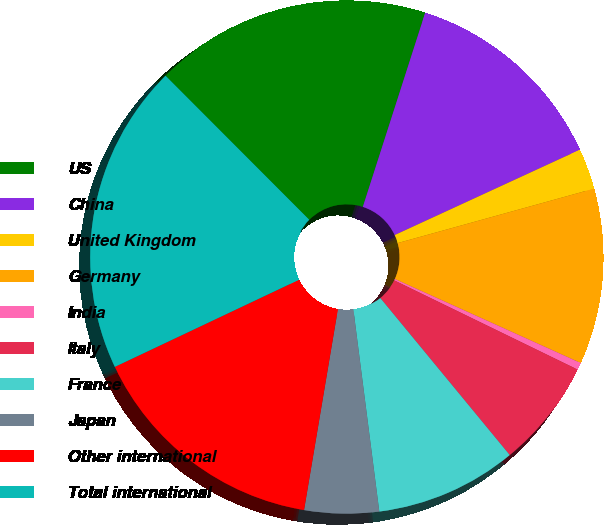Convert chart. <chart><loc_0><loc_0><loc_500><loc_500><pie_chart><fcel>US<fcel>China<fcel>United Kingdom<fcel>Germany<fcel>India<fcel>Italy<fcel>France<fcel>Japan<fcel>Other international<fcel>Total international<nl><fcel>17.43%<fcel>13.18%<fcel>2.57%<fcel>11.06%<fcel>0.45%<fcel>6.82%<fcel>8.94%<fcel>4.69%<fcel>15.31%<fcel>19.55%<nl></chart> 